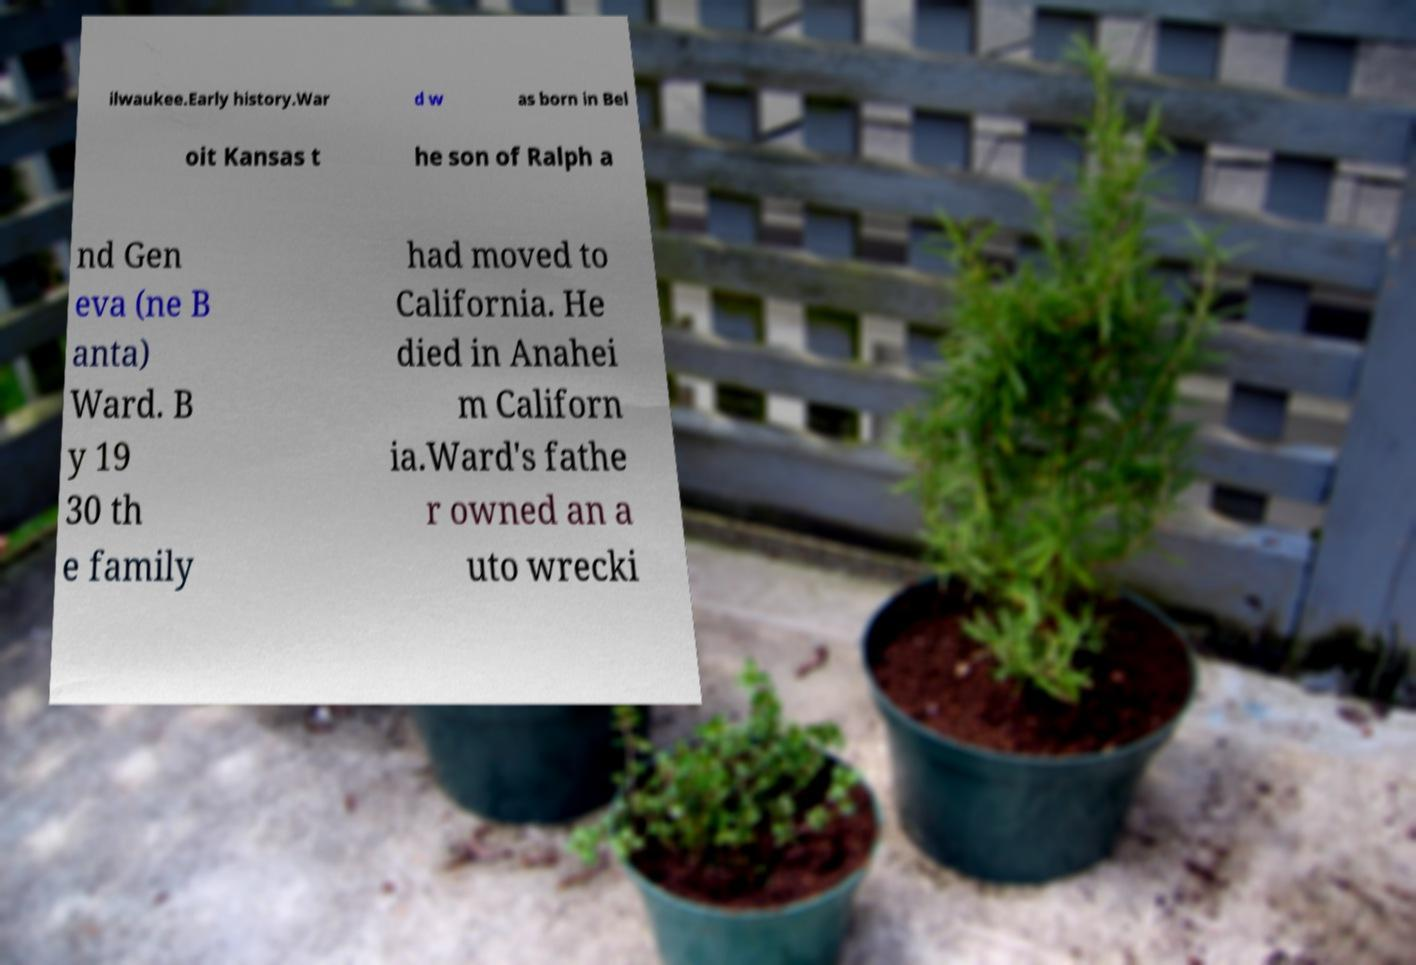Could you extract and type out the text from this image? ilwaukee.Early history.War d w as born in Bel oit Kansas t he son of Ralph a nd Gen eva (ne B anta) Ward. B y 19 30 th e family had moved to California. He died in Anahei m Californ ia.Ward's fathe r owned an a uto wrecki 